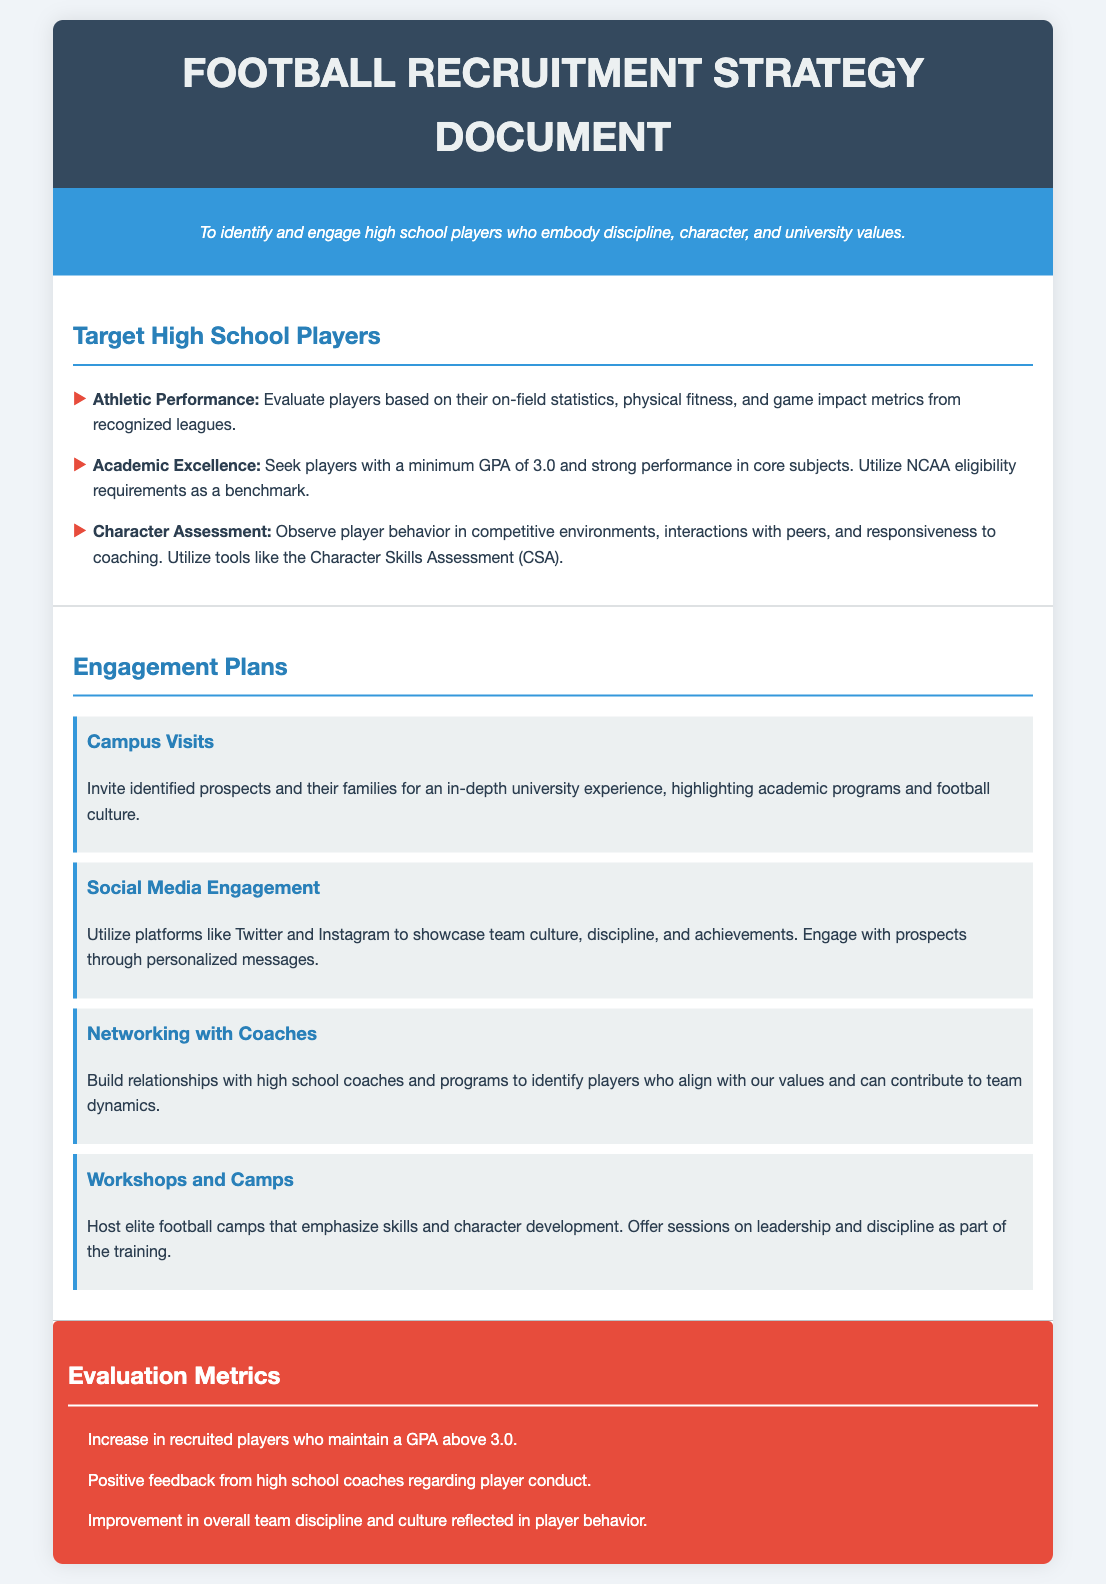What is the minimum GPA required for target players? The document states that players should have a minimum GPA of 3.0.
Answer: 3.0 What tool is used for character assessment? The document mentions the Character Skills Assessment (CSA) as a tool for character assessment.
Answer: Character Skills Assessment (CSA) What is one benefit of campus visits? The document highlights that campus visits provide an in-depth university experience for prospects and their families.
Answer: In-depth university experience What is one platform used for social media engagement? The document specifies Twitter as one of the platforms for engaging with prospects.
Answer: Twitter How many evaluation metrics are listed in the document? The document lists three evaluation metrics for the recruitment strategy.
Answer: 3 What does the recruitment strategy prioritize alongside athletic performance? The recruitment strategy also prioritizes academic excellence as a key criterion for selection.
Answer: Academic excellence What type of camps are hosted according to the engagement plans? The engagement plans include hosting elite football camps emphasizing skills and character development.
Answer: Elite football camps Who should relationships be built with according to the engagement strategy? Relationships should be built with high school coaches to help identify suitable players.
Answer: High school coaches 